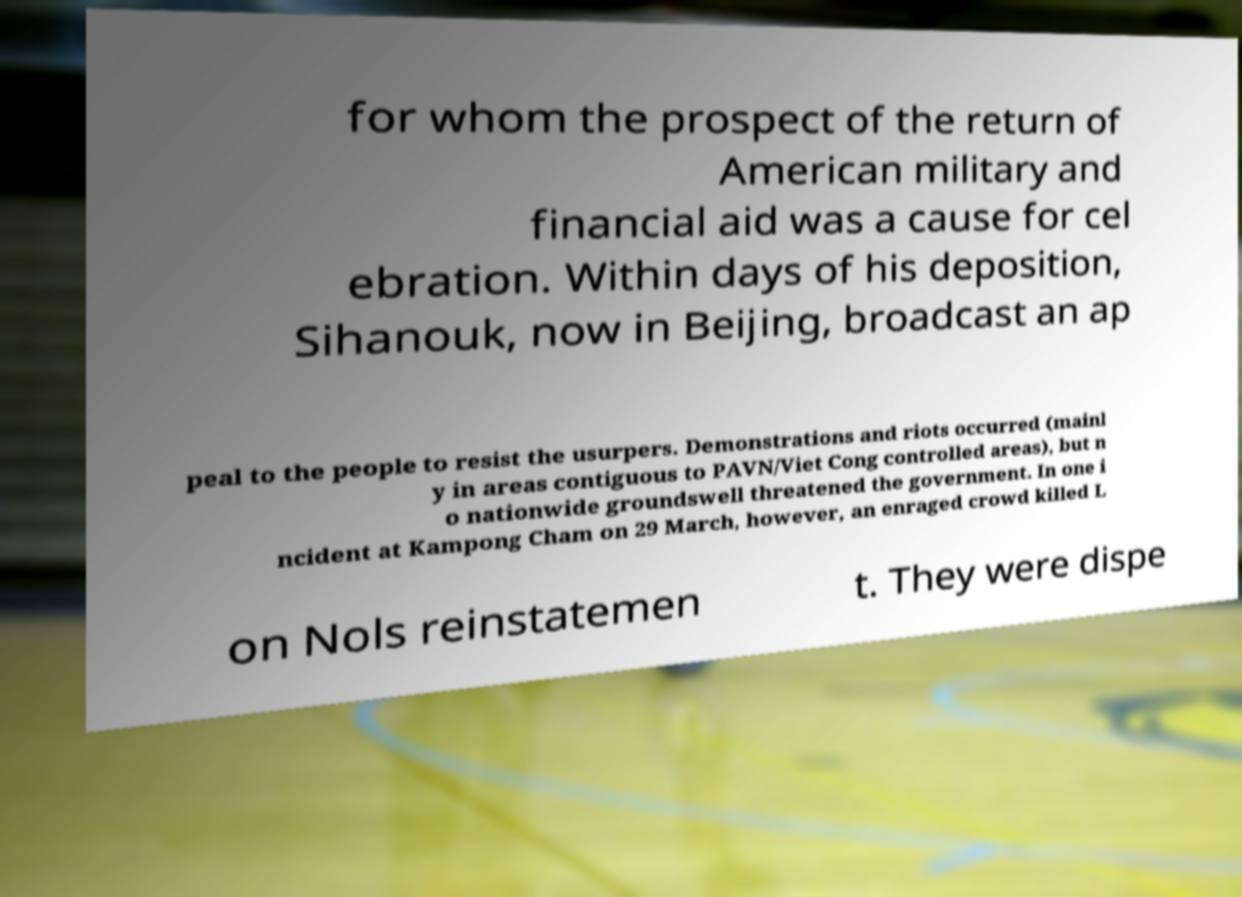Could you extract and type out the text from this image? for whom the prospect of the return of American military and financial aid was a cause for cel ebration. Within days of his deposition, Sihanouk, now in Beijing, broadcast an ap peal to the people to resist the usurpers. Demonstrations and riots occurred (mainl y in areas contiguous to PAVN/Viet Cong controlled areas), but n o nationwide groundswell threatened the government. In one i ncident at Kampong Cham on 29 March, however, an enraged crowd killed L on Nols reinstatemen t. They were dispe 